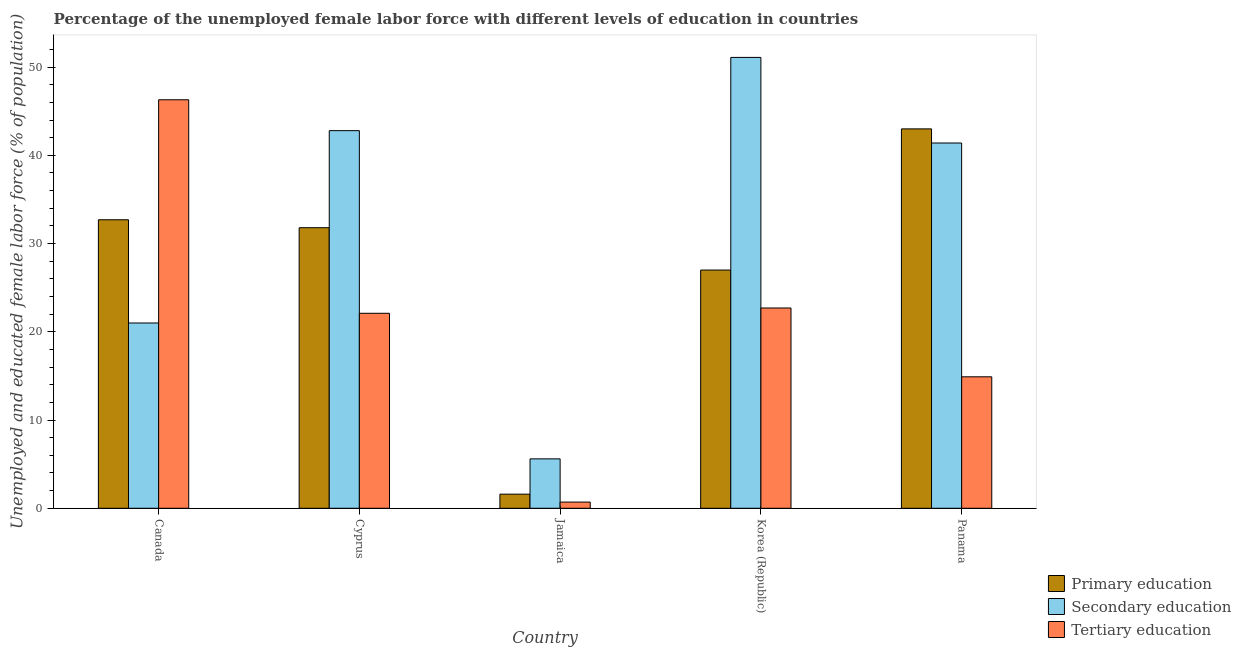How many different coloured bars are there?
Your response must be concise. 3. How many groups of bars are there?
Provide a short and direct response. 5. How many bars are there on the 2nd tick from the left?
Your response must be concise. 3. What is the label of the 2nd group of bars from the left?
Provide a short and direct response. Cyprus. Across all countries, what is the minimum percentage of female labor force who received tertiary education?
Keep it short and to the point. 0.7. In which country was the percentage of female labor force who received primary education maximum?
Make the answer very short. Panama. In which country was the percentage of female labor force who received primary education minimum?
Your answer should be compact. Jamaica. What is the total percentage of female labor force who received secondary education in the graph?
Your answer should be compact. 161.9. What is the difference between the percentage of female labor force who received secondary education in Canada and that in Jamaica?
Keep it short and to the point. 15.4. What is the difference between the percentage of female labor force who received tertiary education in Cyprus and the percentage of female labor force who received primary education in Panama?
Your answer should be very brief. -20.9. What is the average percentage of female labor force who received primary education per country?
Ensure brevity in your answer.  27.22. What is the difference between the percentage of female labor force who received secondary education and percentage of female labor force who received tertiary education in Canada?
Give a very brief answer. -25.3. In how many countries, is the percentage of female labor force who received tertiary education greater than 50 %?
Provide a succinct answer. 0. What is the ratio of the percentage of female labor force who received tertiary education in Cyprus to that in Jamaica?
Give a very brief answer. 31.57. Is the percentage of female labor force who received secondary education in Canada less than that in Cyprus?
Ensure brevity in your answer.  Yes. What is the difference between the highest and the second highest percentage of female labor force who received tertiary education?
Give a very brief answer. 23.6. What is the difference between the highest and the lowest percentage of female labor force who received primary education?
Provide a succinct answer. 41.4. In how many countries, is the percentage of female labor force who received primary education greater than the average percentage of female labor force who received primary education taken over all countries?
Your answer should be very brief. 3. Is the sum of the percentage of female labor force who received secondary education in Canada and Panama greater than the maximum percentage of female labor force who received primary education across all countries?
Your response must be concise. Yes. What does the 2nd bar from the right in Jamaica represents?
Keep it short and to the point. Secondary education. Are all the bars in the graph horizontal?
Make the answer very short. No. How many countries are there in the graph?
Your response must be concise. 5. Are the values on the major ticks of Y-axis written in scientific E-notation?
Ensure brevity in your answer.  No. Where does the legend appear in the graph?
Your answer should be compact. Bottom right. How are the legend labels stacked?
Make the answer very short. Vertical. What is the title of the graph?
Your response must be concise. Percentage of the unemployed female labor force with different levels of education in countries. Does "Social Insurance" appear as one of the legend labels in the graph?
Offer a very short reply. No. What is the label or title of the Y-axis?
Offer a terse response. Unemployed and educated female labor force (% of population). What is the Unemployed and educated female labor force (% of population) of Primary education in Canada?
Your answer should be compact. 32.7. What is the Unemployed and educated female labor force (% of population) of Secondary education in Canada?
Make the answer very short. 21. What is the Unemployed and educated female labor force (% of population) of Tertiary education in Canada?
Your answer should be very brief. 46.3. What is the Unemployed and educated female labor force (% of population) in Primary education in Cyprus?
Offer a terse response. 31.8. What is the Unemployed and educated female labor force (% of population) of Secondary education in Cyprus?
Ensure brevity in your answer.  42.8. What is the Unemployed and educated female labor force (% of population) in Tertiary education in Cyprus?
Offer a very short reply. 22.1. What is the Unemployed and educated female labor force (% of population) in Primary education in Jamaica?
Provide a short and direct response. 1.6. What is the Unemployed and educated female labor force (% of population) of Secondary education in Jamaica?
Make the answer very short. 5.6. What is the Unemployed and educated female labor force (% of population) in Tertiary education in Jamaica?
Ensure brevity in your answer.  0.7. What is the Unemployed and educated female labor force (% of population) in Primary education in Korea (Republic)?
Offer a very short reply. 27. What is the Unemployed and educated female labor force (% of population) of Secondary education in Korea (Republic)?
Ensure brevity in your answer.  51.1. What is the Unemployed and educated female labor force (% of population) of Tertiary education in Korea (Republic)?
Give a very brief answer. 22.7. What is the Unemployed and educated female labor force (% of population) in Secondary education in Panama?
Give a very brief answer. 41.4. What is the Unemployed and educated female labor force (% of population) in Tertiary education in Panama?
Keep it short and to the point. 14.9. Across all countries, what is the maximum Unemployed and educated female labor force (% of population) in Primary education?
Your response must be concise. 43. Across all countries, what is the maximum Unemployed and educated female labor force (% of population) of Secondary education?
Keep it short and to the point. 51.1. Across all countries, what is the maximum Unemployed and educated female labor force (% of population) of Tertiary education?
Ensure brevity in your answer.  46.3. Across all countries, what is the minimum Unemployed and educated female labor force (% of population) in Primary education?
Provide a short and direct response. 1.6. Across all countries, what is the minimum Unemployed and educated female labor force (% of population) of Secondary education?
Provide a short and direct response. 5.6. Across all countries, what is the minimum Unemployed and educated female labor force (% of population) of Tertiary education?
Offer a terse response. 0.7. What is the total Unemployed and educated female labor force (% of population) of Primary education in the graph?
Offer a very short reply. 136.1. What is the total Unemployed and educated female labor force (% of population) of Secondary education in the graph?
Provide a succinct answer. 161.9. What is the total Unemployed and educated female labor force (% of population) of Tertiary education in the graph?
Keep it short and to the point. 106.7. What is the difference between the Unemployed and educated female labor force (% of population) of Primary education in Canada and that in Cyprus?
Offer a terse response. 0.9. What is the difference between the Unemployed and educated female labor force (% of population) of Secondary education in Canada and that in Cyprus?
Your answer should be compact. -21.8. What is the difference between the Unemployed and educated female labor force (% of population) in Tertiary education in Canada and that in Cyprus?
Your answer should be compact. 24.2. What is the difference between the Unemployed and educated female labor force (% of population) in Primary education in Canada and that in Jamaica?
Offer a terse response. 31.1. What is the difference between the Unemployed and educated female labor force (% of population) in Tertiary education in Canada and that in Jamaica?
Make the answer very short. 45.6. What is the difference between the Unemployed and educated female labor force (% of population) of Secondary education in Canada and that in Korea (Republic)?
Give a very brief answer. -30.1. What is the difference between the Unemployed and educated female labor force (% of population) in Tertiary education in Canada and that in Korea (Republic)?
Your answer should be compact. 23.6. What is the difference between the Unemployed and educated female labor force (% of population) in Primary education in Canada and that in Panama?
Offer a very short reply. -10.3. What is the difference between the Unemployed and educated female labor force (% of population) of Secondary education in Canada and that in Panama?
Your answer should be very brief. -20.4. What is the difference between the Unemployed and educated female labor force (% of population) in Tertiary education in Canada and that in Panama?
Give a very brief answer. 31.4. What is the difference between the Unemployed and educated female labor force (% of population) in Primary education in Cyprus and that in Jamaica?
Keep it short and to the point. 30.2. What is the difference between the Unemployed and educated female labor force (% of population) in Secondary education in Cyprus and that in Jamaica?
Provide a short and direct response. 37.2. What is the difference between the Unemployed and educated female labor force (% of population) in Tertiary education in Cyprus and that in Jamaica?
Offer a terse response. 21.4. What is the difference between the Unemployed and educated female labor force (% of population) in Primary education in Cyprus and that in Panama?
Provide a short and direct response. -11.2. What is the difference between the Unemployed and educated female labor force (% of population) in Primary education in Jamaica and that in Korea (Republic)?
Keep it short and to the point. -25.4. What is the difference between the Unemployed and educated female labor force (% of population) in Secondary education in Jamaica and that in Korea (Republic)?
Ensure brevity in your answer.  -45.5. What is the difference between the Unemployed and educated female labor force (% of population) of Tertiary education in Jamaica and that in Korea (Republic)?
Your response must be concise. -22. What is the difference between the Unemployed and educated female labor force (% of population) of Primary education in Jamaica and that in Panama?
Keep it short and to the point. -41.4. What is the difference between the Unemployed and educated female labor force (% of population) of Secondary education in Jamaica and that in Panama?
Offer a very short reply. -35.8. What is the difference between the Unemployed and educated female labor force (% of population) of Tertiary education in Jamaica and that in Panama?
Offer a very short reply. -14.2. What is the difference between the Unemployed and educated female labor force (% of population) of Tertiary education in Korea (Republic) and that in Panama?
Make the answer very short. 7.8. What is the difference between the Unemployed and educated female labor force (% of population) of Primary education in Canada and the Unemployed and educated female labor force (% of population) of Tertiary education in Cyprus?
Ensure brevity in your answer.  10.6. What is the difference between the Unemployed and educated female labor force (% of population) in Primary education in Canada and the Unemployed and educated female labor force (% of population) in Secondary education in Jamaica?
Offer a terse response. 27.1. What is the difference between the Unemployed and educated female labor force (% of population) in Secondary education in Canada and the Unemployed and educated female labor force (% of population) in Tertiary education in Jamaica?
Make the answer very short. 20.3. What is the difference between the Unemployed and educated female labor force (% of population) in Primary education in Canada and the Unemployed and educated female labor force (% of population) in Secondary education in Korea (Republic)?
Provide a short and direct response. -18.4. What is the difference between the Unemployed and educated female labor force (% of population) of Primary education in Canada and the Unemployed and educated female labor force (% of population) of Secondary education in Panama?
Your answer should be very brief. -8.7. What is the difference between the Unemployed and educated female labor force (% of population) of Primary education in Canada and the Unemployed and educated female labor force (% of population) of Tertiary education in Panama?
Your answer should be compact. 17.8. What is the difference between the Unemployed and educated female labor force (% of population) in Secondary education in Canada and the Unemployed and educated female labor force (% of population) in Tertiary education in Panama?
Your response must be concise. 6.1. What is the difference between the Unemployed and educated female labor force (% of population) in Primary education in Cyprus and the Unemployed and educated female labor force (% of population) in Secondary education in Jamaica?
Your answer should be compact. 26.2. What is the difference between the Unemployed and educated female labor force (% of population) of Primary education in Cyprus and the Unemployed and educated female labor force (% of population) of Tertiary education in Jamaica?
Your answer should be very brief. 31.1. What is the difference between the Unemployed and educated female labor force (% of population) in Secondary education in Cyprus and the Unemployed and educated female labor force (% of population) in Tertiary education in Jamaica?
Offer a terse response. 42.1. What is the difference between the Unemployed and educated female labor force (% of population) in Primary education in Cyprus and the Unemployed and educated female labor force (% of population) in Secondary education in Korea (Republic)?
Keep it short and to the point. -19.3. What is the difference between the Unemployed and educated female labor force (% of population) of Primary education in Cyprus and the Unemployed and educated female labor force (% of population) of Tertiary education in Korea (Republic)?
Make the answer very short. 9.1. What is the difference between the Unemployed and educated female labor force (% of population) of Secondary education in Cyprus and the Unemployed and educated female labor force (% of population) of Tertiary education in Korea (Republic)?
Offer a very short reply. 20.1. What is the difference between the Unemployed and educated female labor force (% of population) of Primary education in Cyprus and the Unemployed and educated female labor force (% of population) of Tertiary education in Panama?
Ensure brevity in your answer.  16.9. What is the difference between the Unemployed and educated female labor force (% of population) in Secondary education in Cyprus and the Unemployed and educated female labor force (% of population) in Tertiary education in Panama?
Keep it short and to the point. 27.9. What is the difference between the Unemployed and educated female labor force (% of population) in Primary education in Jamaica and the Unemployed and educated female labor force (% of population) in Secondary education in Korea (Republic)?
Give a very brief answer. -49.5. What is the difference between the Unemployed and educated female labor force (% of population) of Primary education in Jamaica and the Unemployed and educated female labor force (% of population) of Tertiary education in Korea (Republic)?
Provide a short and direct response. -21.1. What is the difference between the Unemployed and educated female labor force (% of population) of Secondary education in Jamaica and the Unemployed and educated female labor force (% of population) of Tertiary education in Korea (Republic)?
Keep it short and to the point. -17.1. What is the difference between the Unemployed and educated female labor force (% of population) in Primary education in Jamaica and the Unemployed and educated female labor force (% of population) in Secondary education in Panama?
Your response must be concise. -39.8. What is the difference between the Unemployed and educated female labor force (% of population) of Primary education in Jamaica and the Unemployed and educated female labor force (% of population) of Tertiary education in Panama?
Your answer should be very brief. -13.3. What is the difference between the Unemployed and educated female labor force (% of population) in Secondary education in Jamaica and the Unemployed and educated female labor force (% of population) in Tertiary education in Panama?
Give a very brief answer. -9.3. What is the difference between the Unemployed and educated female labor force (% of population) in Primary education in Korea (Republic) and the Unemployed and educated female labor force (% of population) in Secondary education in Panama?
Offer a very short reply. -14.4. What is the difference between the Unemployed and educated female labor force (% of population) in Primary education in Korea (Republic) and the Unemployed and educated female labor force (% of population) in Tertiary education in Panama?
Your answer should be very brief. 12.1. What is the difference between the Unemployed and educated female labor force (% of population) in Secondary education in Korea (Republic) and the Unemployed and educated female labor force (% of population) in Tertiary education in Panama?
Keep it short and to the point. 36.2. What is the average Unemployed and educated female labor force (% of population) in Primary education per country?
Give a very brief answer. 27.22. What is the average Unemployed and educated female labor force (% of population) of Secondary education per country?
Keep it short and to the point. 32.38. What is the average Unemployed and educated female labor force (% of population) in Tertiary education per country?
Your answer should be compact. 21.34. What is the difference between the Unemployed and educated female labor force (% of population) of Secondary education and Unemployed and educated female labor force (% of population) of Tertiary education in Canada?
Your response must be concise. -25.3. What is the difference between the Unemployed and educated female labor force (% of population) in Primary education and Unemployed and educated female labor force (% of population) in Tertiary education in Cyprus?
Ensure brevity in your answer.  9.7. What is the difference between the Unemployed and educated female labor force (% of population) of Secondary education and Unemployed and educated female labor force (% of population) of Tertiary education in Cyprus?
Make the answer very short. 20.7. What is the difference between the Unemployed and educated female labor force (% of population) of Primary education and Unemployed and educated female labor force (% of population) of Secondary education in Jamaica?
Offer a terse response. -4. What is the difference between the Unemployed and educated female labor force (% of population) of Primary education and Unemployed and educated female labor force (% of population) of Tertiary education in Jamaica?
Offer a terse response. 0.9. What is the difference between the Unemployed and educated female labor force (% of population) of Primary education and Unemployed and educated female labor force (% of population) of Secondary education in Korea (Republic)?
Ensure brevity in your answer.  -24.1. What is the difference between the Unemployed and educated female labor force (% of population) in Secondary education and Unemployed and educated female labor force (% of population) in Tertiary education in Korea (Republic)?
Your response must be concise. 28.4. What is the difference between the Unemployed and educated female labor force (% of population) in Primary education and Unemployed and educated female labor force (% of population) in Secondary education in Panama?
Offer a terse response. 1.6. What is the difference between the Unemployed and educated female labor force (% of population) of Primary education and Unemployed and educated female labor force (% of population) of Tertiary education in Panama?
Ensure brevity in your answer.  28.1. What is the difference between the Unemployed and educated female labor force (% of population) in Secondary education and Unemployed and educated female labor force (% of population) in Tertiary education in Panama?
Your answer should be compact. 26.5. What is the ratio of the Unemployed and educated female labor force (% of population) of Primary education in Canada to that in Cyprus?
Your answer should be very brief. 1.03. What is the ratio of the Unemployed and educated female labor force (% of population) of Secondary education in Canada to that in Cyprus?
Provide a succinct answer. 0.49. What is the ratio of the Unemployed and educated female labor force (% of population) in Tertiary education in Canada to that in Cyprus?
Offer a very short reply. 2.1. What is the ratio of the Unemployed and educated female labor force (% of population) in Primary education in Canada to that in Jamaica?
Keep it short and to the point. 20.44. What is the ratio of the Unemployed and educated female labor force (% of population) of Secondary education in Canada to that in Jamaica?
Your answer should be compact. 3.75. What is the ratio of the Unemployed and educated female labor force (% of population) of Tertiary education in Canada to that in Jamaica?
Ensure brevity in your answer.  66.14. What is the ratio of the Unemployed and educated female labor force (% of population) of Primary education in Canada to that in Korea (Republic)?
Your answer should be very brief. 1.21. What is the ratio of the Unemployed and educated female labor force (% of population) in Secondary education in Canada to that in Korea (Republic)?
Make the answer very short. 0.41. What is the ratio of the Unemployed and educated female labor force (% of population) of Tertiary education in Canada to that in Korea (Republic)?
Offer a very short reply. 2.04. What is the ratio of the Unemployed and educated female labor force (% of population) in Primary education in Canada to that in Panama?
Provide a succinct answer. 0.76. What is the ratio of the Unemployed and educated female labor force (% of population) in Secondary education in Canada to that in Panama?
Your answer should be compact. 0.51. What is the ratio of the Unemployed and educated female labor force (% of population) of Tertiary education in Canada to that in Panama?
Provide a succinct answer. 3.11. What is the ratio of the Unemployed and educated female labor force (% of population) of Primary education in Cyprus to that in Jamaica?
Keep it short and to the point. 19.88. What is the ratio of the Unemployed and educated female labor force (% of population) of Secondary education in Cyprus to that in Jamaica?
Ensure brevity in your answer.  7.64. What is the ratio of the Unemployed and educated female labor force (% of population) of Tertiary education in Cyprus to that in Jamaica?
Make the answer very short. 31.57. What is the ratio of the Unemployed and educated female labor force (% of population) of Primary education in Cyprus to that in Korea (Republic)?
Make the answer very short. 1.18. What is the ratio of the Unemployed and educated female labor force (% of population) in Secondary education in Cyprus to that in Korea (Republic)?
Ensure brevity in your answer.  0.84. What is the ratio of the Unemployed and educated female labor force (% of population) of Tertiary education in Cyprus to that in Korea (Republic)?
Offer a terse response. 0.97. What is the ratio of the Unemployed and educated female labor force (% of population) of Primary education in Cyprus to that in Panama?
Offer a very short reply. 0.74. What is the ratio of the Unemployed and educated female labor force (% of population) of Secondary education in Cyprus to that in Panama?
Give a very brief answer. 1.03. What is the ratio of the Unemployed and educated female labor force (% of population) in Tertiary education in Cyprus to that in Panama?
Offer a terse response. 1.48. What is the ratio of the Unemployed and educated female labor force (% of population) in Primary education in Jamaica to that in Korea (Republic)?
Make the answer very short. 0.06. What is the ratio of the Unemployed and educated female labor force (% of population) of Secondary education in Jamaica to that in Korea (Republic)?
Make the answer very short. 0.11. What is the ratio of the Unemployed and educated female labor force (% of population) in Tertiary education in Jamaica to that in Korea (Republic)?
Provide a short and direct response. 0.03. What is the ratio of the Unemployed and educated female labor force (% of population) of Primary education in Jamaica to that in Panama?
Ensure brevity in your answer.  0.04. What is the ratio of the Unemployed and educated female labor force (% of population) in Secondary education in Jamaica to that in Panama?
Your response must be concise. 0.14. What is the ratio of the Unemployed and educated female labor force (% of population) of Tertiary education in Jamaica to that in Panama?
Give a very brief answer. 0.05. What is the ratio of the Unemployed and educated female labor force (% of population) of Primary education in Korea (Republic) to that in Panama?
Provide a short and direct response. 0.63. What is the ratio of the Unemployed and educated female labor force (% of population) of Secondary education in Korea (Republic) to that in Panama?
Make the answer very short. 1.23. What is the ratio of the Unemployed and educated female labor force (% of population) in Tertiary education in Korea (Republic) to that in Panama?
Your response must be concise. 1.52. What is the difference between the highest and the second highest Unemployed and educated female labor force (% of population) in Secondary education?
Make the answer very short. 8.3. What is the difference between the highest and the second highest Unemployed and educated female labor force (% of population) of Tertiary education?
Make the answer very short. 23.6. What is the difference between the highest and the lowest Unemployed and educated female labor force (% of population) of Primary education?
Make the answer very short. 41.4. What is the difference between the highest and the lowest Unemployed and educated female labor force (% of population) in Secondary education?
Give a very brief answer. 45.5. What is the difference between the highest and the lowest Unemployed and educated female labor force (% of population) in Tertiary education?
Your response must be concise. 45.6. 